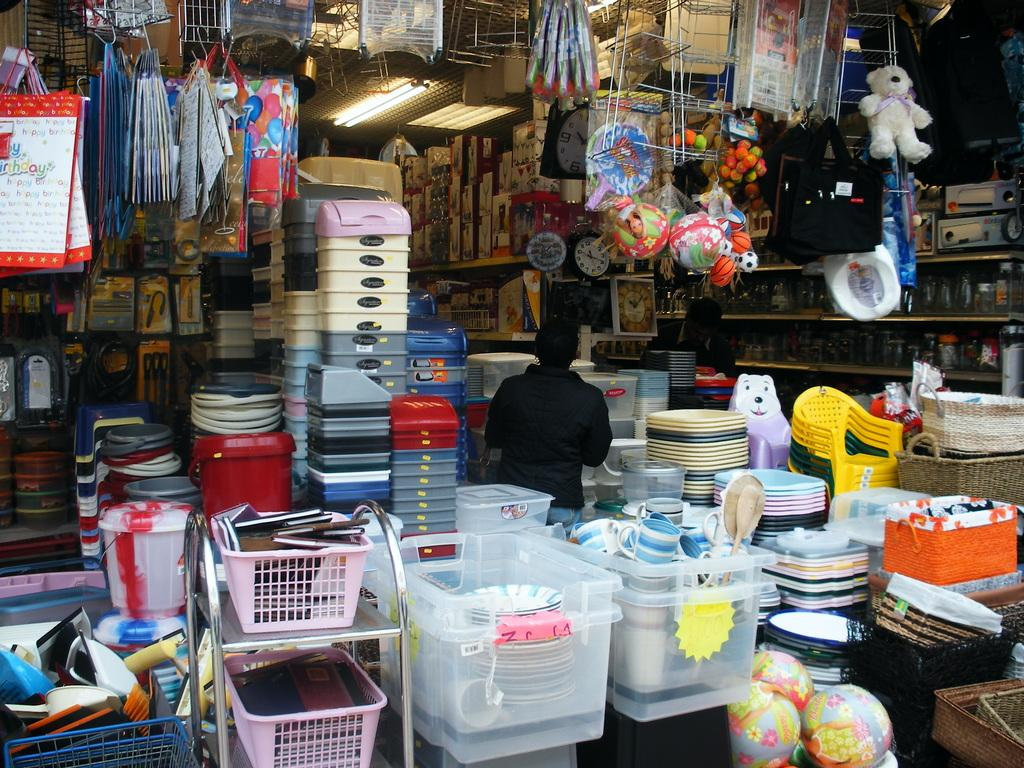<image>
Give a short and clear explanation of the subsequent image. Various kinck nacks including bags that say Happy Birthday and balls labeled by Barbi 